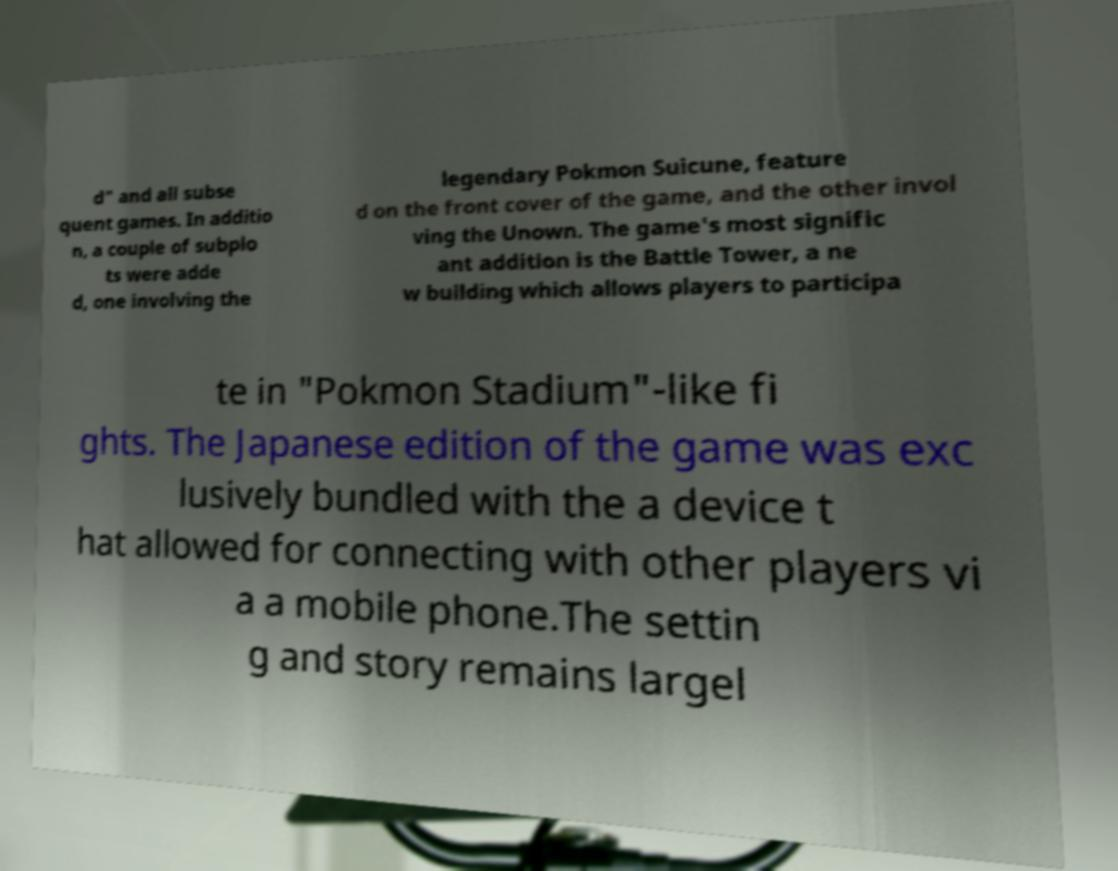Can you read and provide the text displayed in the image?This photo seems to have some interesting text. Can you extract and type it out for me? d" and all subse quent games. In additio n, a couple of subplo ts were adde d, one involving the legendary Pokmon Suicune, feature d on the front cover of the game, and the other invol ving the Unown. The game's most signific ant addition is the Battle Tower, a ne w building which allows players to participa te in "Pokmon Stadium"-like fi ghts. The Japanese edition of the game was exc lusively bundled with the a device t hat allowed for connecting with other players vi a a mobile phone.The settin g and story remains largel 